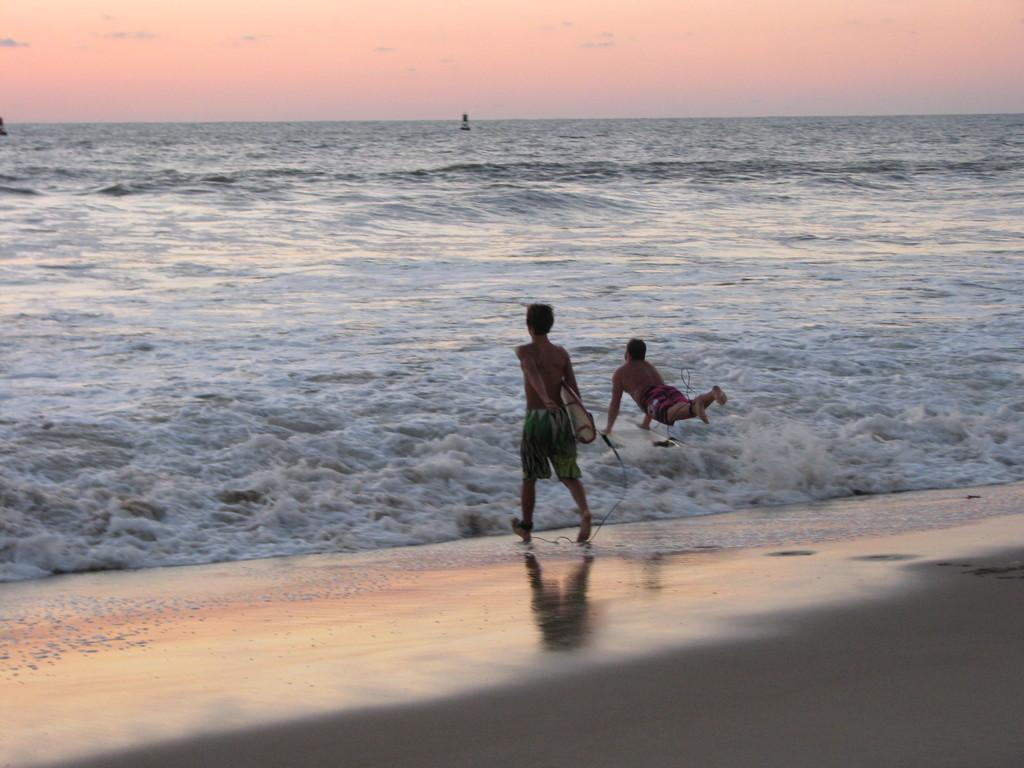How many people are in the image? There are two persons in the image. What can be seen in the water in the image? There are objects in the water. What is visible in the background of the image? The sky is visible in the background of the image. What type of driving is happening in the image? There is no driving present in the image; it features two persons and objects in the water. Is there a crook visible in the image? There is no crook present in the image. 